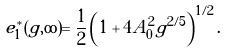Convert formula to latex. <formula><loc_0><loc_0><loc_500><loc_500>e _ { 1 } ^ { * } ( g , \infty ) = \frac { 1 } { 2 } \left ( 1 + 4 A _ { 0 } ^ { 2 } g ^ { 2 / 5 } \right ) ^ { 1 / 2 } .</formula> 